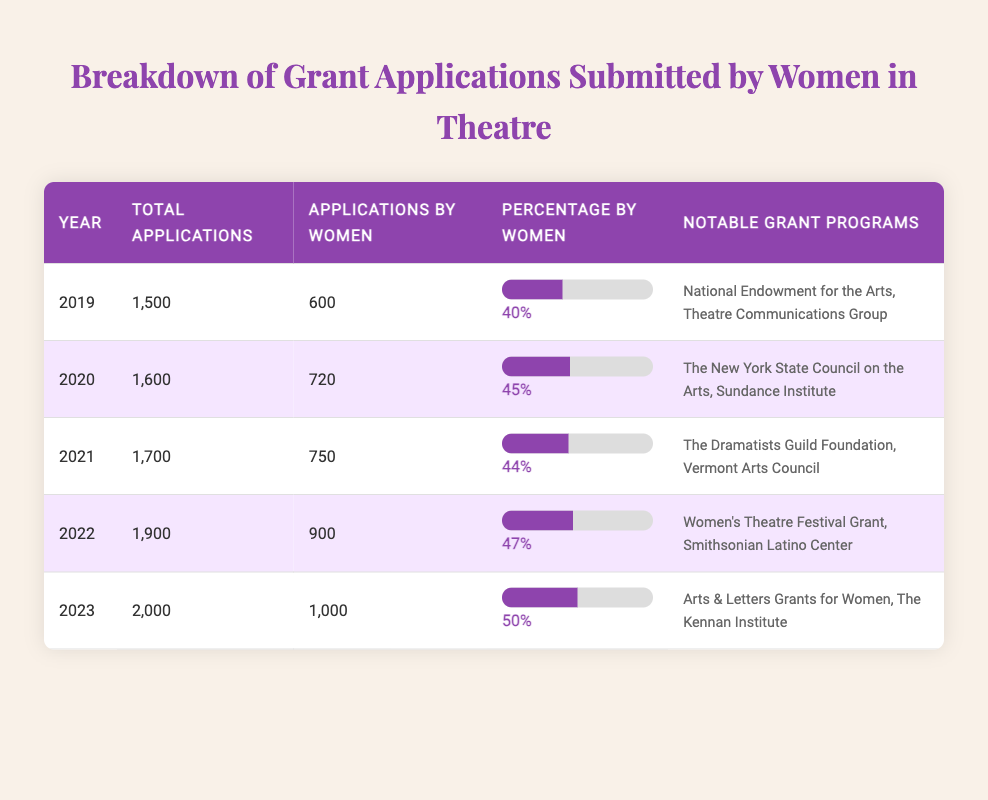What year had the highest percentage of grant applications submitted by women? The year 2023 had the highest percentage of 50%. By looking at the "Percentage by Women" column, we see 50% in 2023, which is higher than any other year listed.
Answer: 2023 How many total grant applications were submitted in 2020? The table shows that a total of 1,600 grant applications were submitted in 2020, as indicated in the "Total Applications" column for that year.
Answer: 1,600 Which year had the least number of applications submitted by women? In 2019, 600 applications were submitted by women, which is the lowest compared to all the other years listed. The values in the "Applications by Women" column confirm that 600 is the smallest figure.
Answer: 2019 What is the average percentage of applications by women over these five years? The percentages for each year are 40%, 45%, 44%, 47%, and 50%. Adding them gives 226%, and dividing by 5 gives an average percentage of 45.2%.
Answer: 45.2% In which year did the applications by women first exceed 700? The applications by women exceeded 700 for the first time in 2020, where the count is noted as 720 in the "Applications by Women" column. Previous years (2019) had lower numbers than this.
Answer: 2020 What was the increase in applications by women from 2021 to 2022? The number of applications by women in 2021 was 750, and in 2022 it was 900. The increase is calculated by subtracting 750 from 900, resulting in an increase of 150 applications.
Answer: 150 Is it true that the total number of applications increased every year from 2019 to 2023? Yes, by examining the "Total Applications" column, we see each year shows a greater total: 1,500 in 2019, increasing to 2,000 in 2023, confirming that total applications grew each year.
Answer: Yes How many total applications were submitted from 2019 to 2023 combined? To find the total applications submitted over the five years, we add up 1,500 (2019), 1,600 (2020), 1,700 (2021), 1,900 (2022), and 2,000 (2023), which equals 8,700 total applications.
Answer: 8,700 What percentage of the total submissions in 2022 were made by women? In 2022, there were 900 applications by women out of a total of 1,900 applications. The percentage is calculated as (900 / 1900) * 100 = 47.37%, which is rounded to 47%.
Answer: 47% 